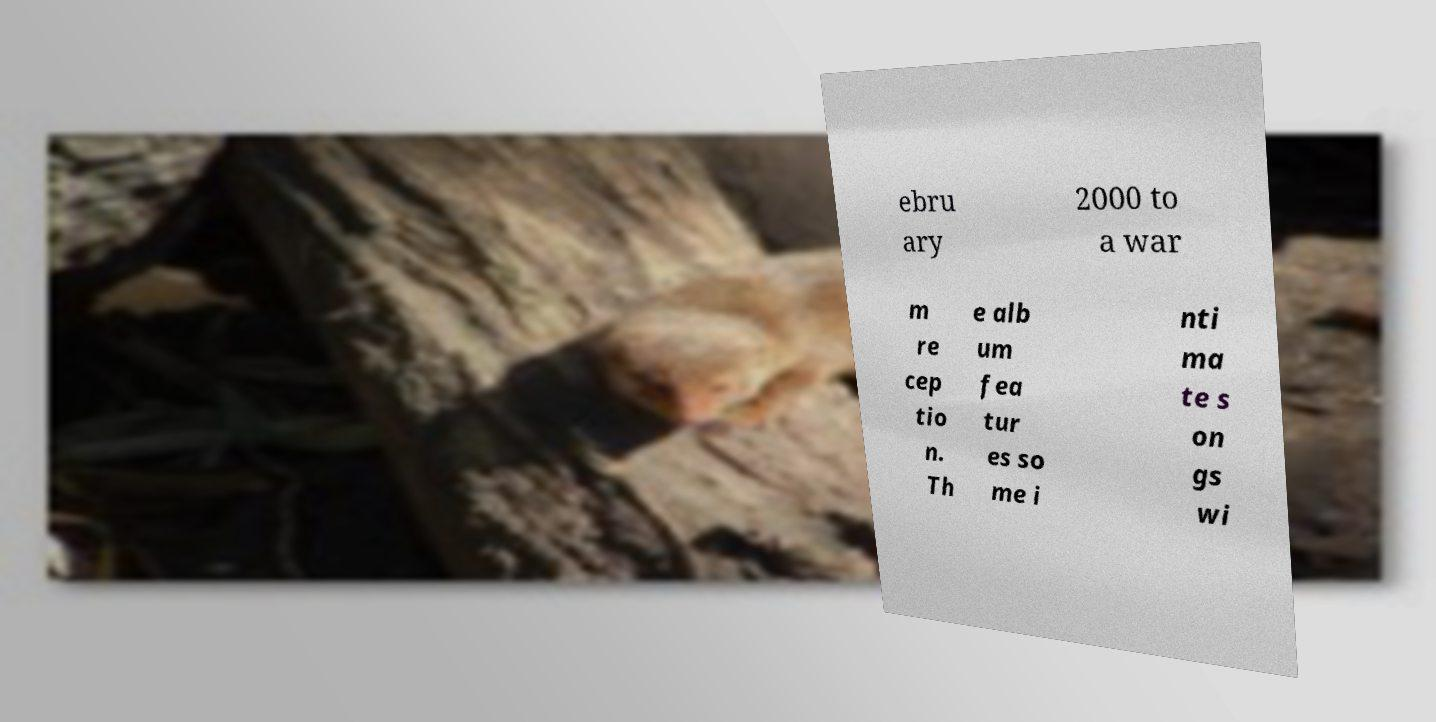For documentation purposes, I need the text within this image transcribed. Could you provide that? ebru ary 2000 to a war m re cep tio n. Th e alb um fea tur es so me i nti ma te s on gs wi 